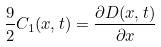Convert formula to latex. <formula><loc_0><loc_0><loc_500><loc_500>\frac { 9 } { 2 } C _ { 1 } ( x , t ) = \frac { \partial D ( x , t ) } { \partial x }</formula> 